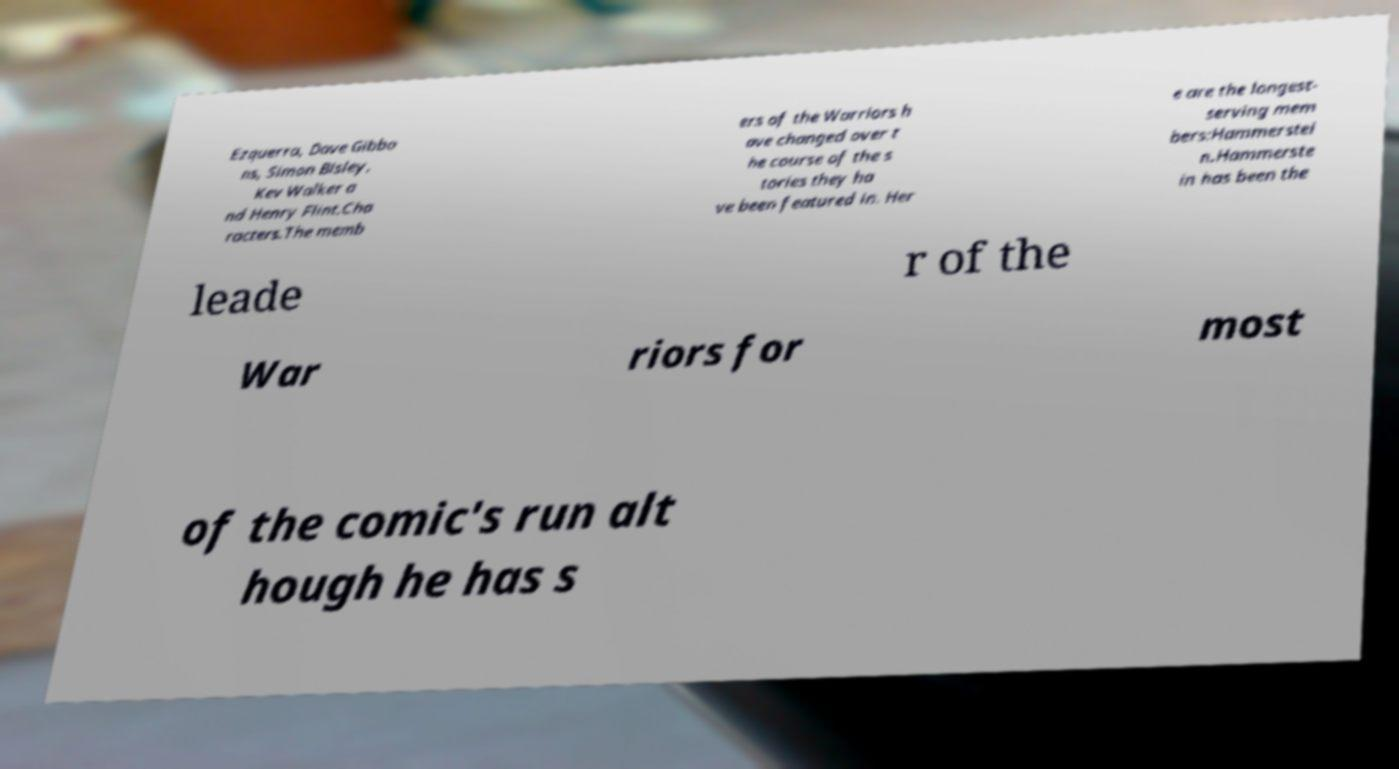I need the written content from this picture converted into text. Can you do that? Ezquerra, Dave Gibbo ns, Simon Bisley, Kev Walker a nd Henry Flint.Cha racters.The memb ers of the Warriors h ave changed over t he course of the s tories they ha ve been featured in. Her e are the longest- serving mem bers:Hammerstei n.Hammerste in has been the leade r of the War riors for most of the comic's run alt hough he has s 